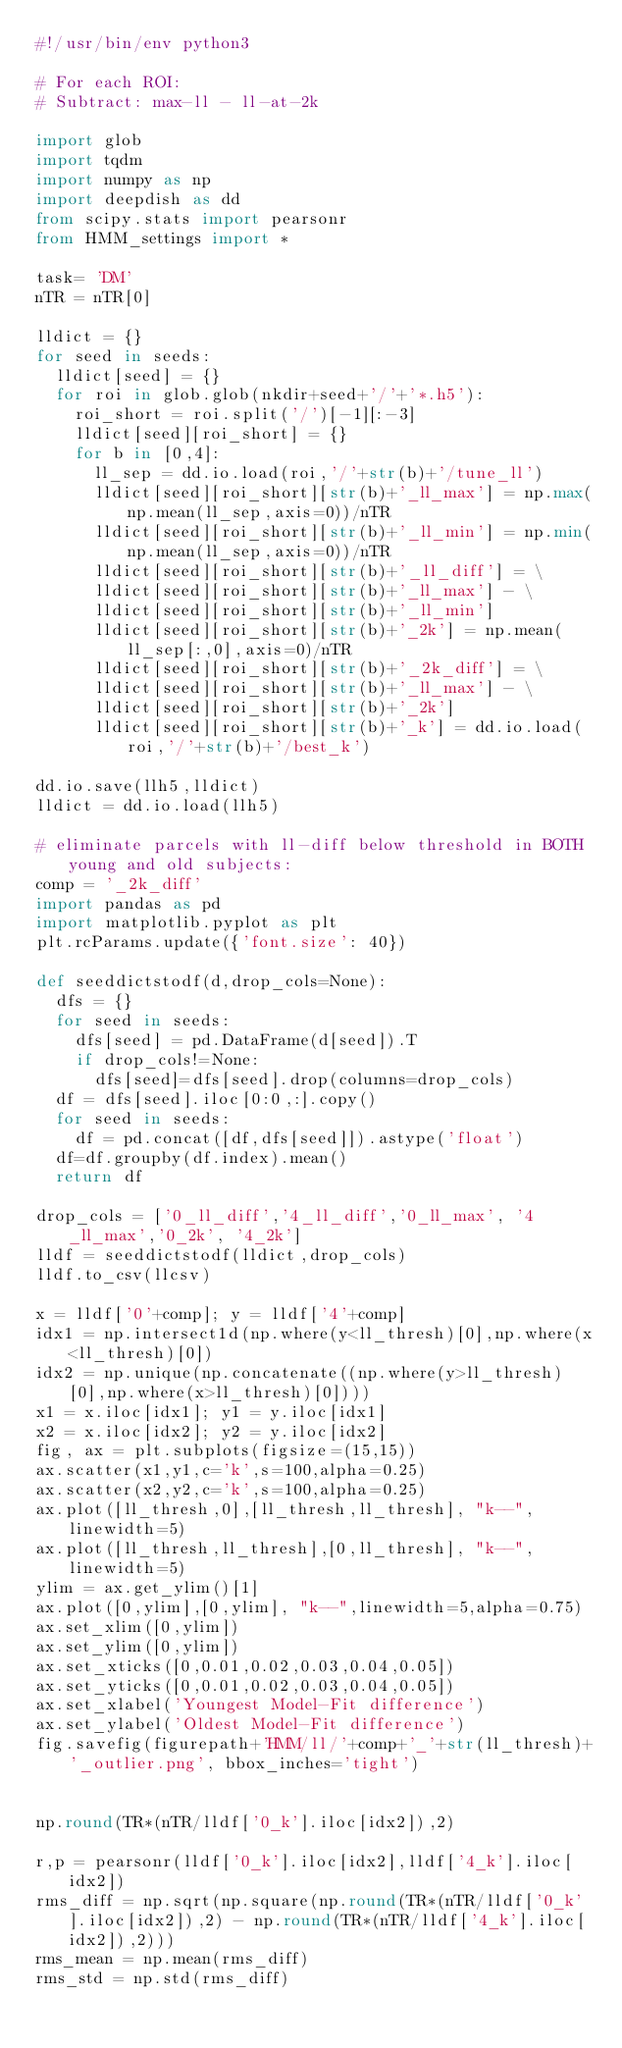<code> <loc_0><loc_0><loc_500><loc_500><_Python_>#!/usr/bin/env python3

# For each ROI:
# Subtract: max-ll - ll-at-2k

import glob
import tqdm
import numpy as np
import deepdish as dd
from scipy.stats import pearsonr
from HMM_settings import *

task= 'DM'
nTR = nTR[0]

lldict = {}
for seed in seeds:
	lldict[seed] = {}
	for roi in glob.glob(nkdir+seed+'/'+'*.h5'):
		roi_short = roi.split('/')[-1][:-3]
		lldict[seed][roi_short] = {}
		for b in [0,4]:
			ll_sep = dd.io.load(roi,'/'+str(b)+'/tune_ll')
			lldict[seed][roi_short][str(b)+'_ll_max'] = np.max(np.mean(ll_sep,axis=0))/nTR
			lldict[seed][roi_short][str(b)+'_ll_min'] = np.min(np.mean(ll_sep,axis=0))/nTR
			lldict[seed][roi_short][str(b)+'_ll_diff'] = \
			lldict[seed][roi_short][str(b)+'_ll_max'] - \
			lldict[seed][roi_short][str(b)+'_ll_min']
			lldict[seed][roi_short][str(b)+'_2k'] = np.mean(ll_sep[:,0],axis=0)/nTR
			lldict[seed][roi_short][str(b)+'_2k_diff'] = \
			lldict[seed][roi_short][str(b)+'_ll_max'] - \
			lldict[seed][roi_short][str(b)+'_2k']
			lldict[seed][roi_short][str(b)+'_k'] = dd.io.load(roi,'/'+str(b)+'/best_k')	
		
dd.io.save(llh5,lldict)
lldict = dd.io.load(llh5)

# eliminate parcels with ll-diff below threshold in BOTH young and old subjects:
comp = '_2k_diff'
import pandas as pd
import matplotlib.pyplot as plt
plt.rcParams.update({'font.size': 40})

def seeddictstodf(d,drop_cols=None):
	dfs = {}
	for seed in seeds:
		dfs[seed] = pd.DataFrame(d[seed]).T
		if drop_cols!=None:
			dfs[seed]=dfs[seed].drop(columns=drop_cols)
	df = dfs[seed].iloc[0:0,:].copy()
	for seed in seeds:
		df = pd.concat([df,dfs[seed]]).astype('float')
	df=df.groupby(df.index).mean()
	return df

drop_cols = ['0_ll_diff','4_ll_diff','0_ll_max', '4_ll_max','0_2k', '4_2k']
lldf = seeddictstodf(lldict,drop_cols)
lldf.to_csv(llcsv)

x = lldf['0'+comp]; y = lldf['4'+comp]
idx1 = np.intersect1d(np.where(y<ll_thresh)[0],np.where(x<ll_thresh)[0])
idx2 = np.unique(np.concatenate((np.where(y>ll_thresh)[0],np.where(x>ll_thresh)[0])))
x1 = x.iloc[idx1]; y1 = y.iloc[idx1]
x2 = x.iloc[idx2]; y2 = y.iloc[idx2]
fig, ax = plt.subplots(figsize=(15,15))
ax.scatter(x1,y1,c='k',s=100,alpha=0.25)
ax.scatter(x2,y2,c='k',s=100,alpha=0.25)
ax.plot([ll_thresh,0],[ll_thresh,ll_thresh], "k--",linewidth=5)
ax.plot([ll_thresh,ll_thresh],[0,ll_thresh], "k--",linewidth=5)
ylim = ax.get_ylim()[1]
ax.plot([0,ylim],[0,ylim], "k--",linewidth=5,alpha=0.75)
ax.set_xlim([0,ylim])
ax.set_ylim([0,ylim])
ax.set_xticks([0,0.01,0.02,0.03,0.04,0.05])
ax.set_yticks([0,0.01,0.02,0.03,0.04,0.05])
ax.set_xlabel('Youngest Model-Fit difference')
ax.set_ylabel('Oldest Model-Fit difference')
fig.savefig(figurepath+'HMM/ll/'+comp+'_'+str(ll_thresh)+'_outlier.png', bbox_inches='tight')


np.round(TR*(nTR/lldf['0_k'].iloc[idx2]),2)

r,p = pearsonr(lldf['0_k'].iloc[idx2],lldf['4_k'].iloc[idx2])
rms_diff = np.sqrt(np.square(np.round(TR*(nTR/lldf['0_k'].iloc[idx2]),2) - np.round(TR*(nTR/lldf['4_k'].iloc[idx2]),2)))
rms_mean = np.mean(rms_diff)
rms_std = np.std(rms_diff)
</code> 